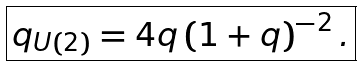Convert formula to latex. <formula><loc_0><loc_0><loc_500><loc_500>\boxed { q _ { U ( 2 ) } = 4 q \left ( 1 + q \right ) ^ { - 2 } . }</formula> 